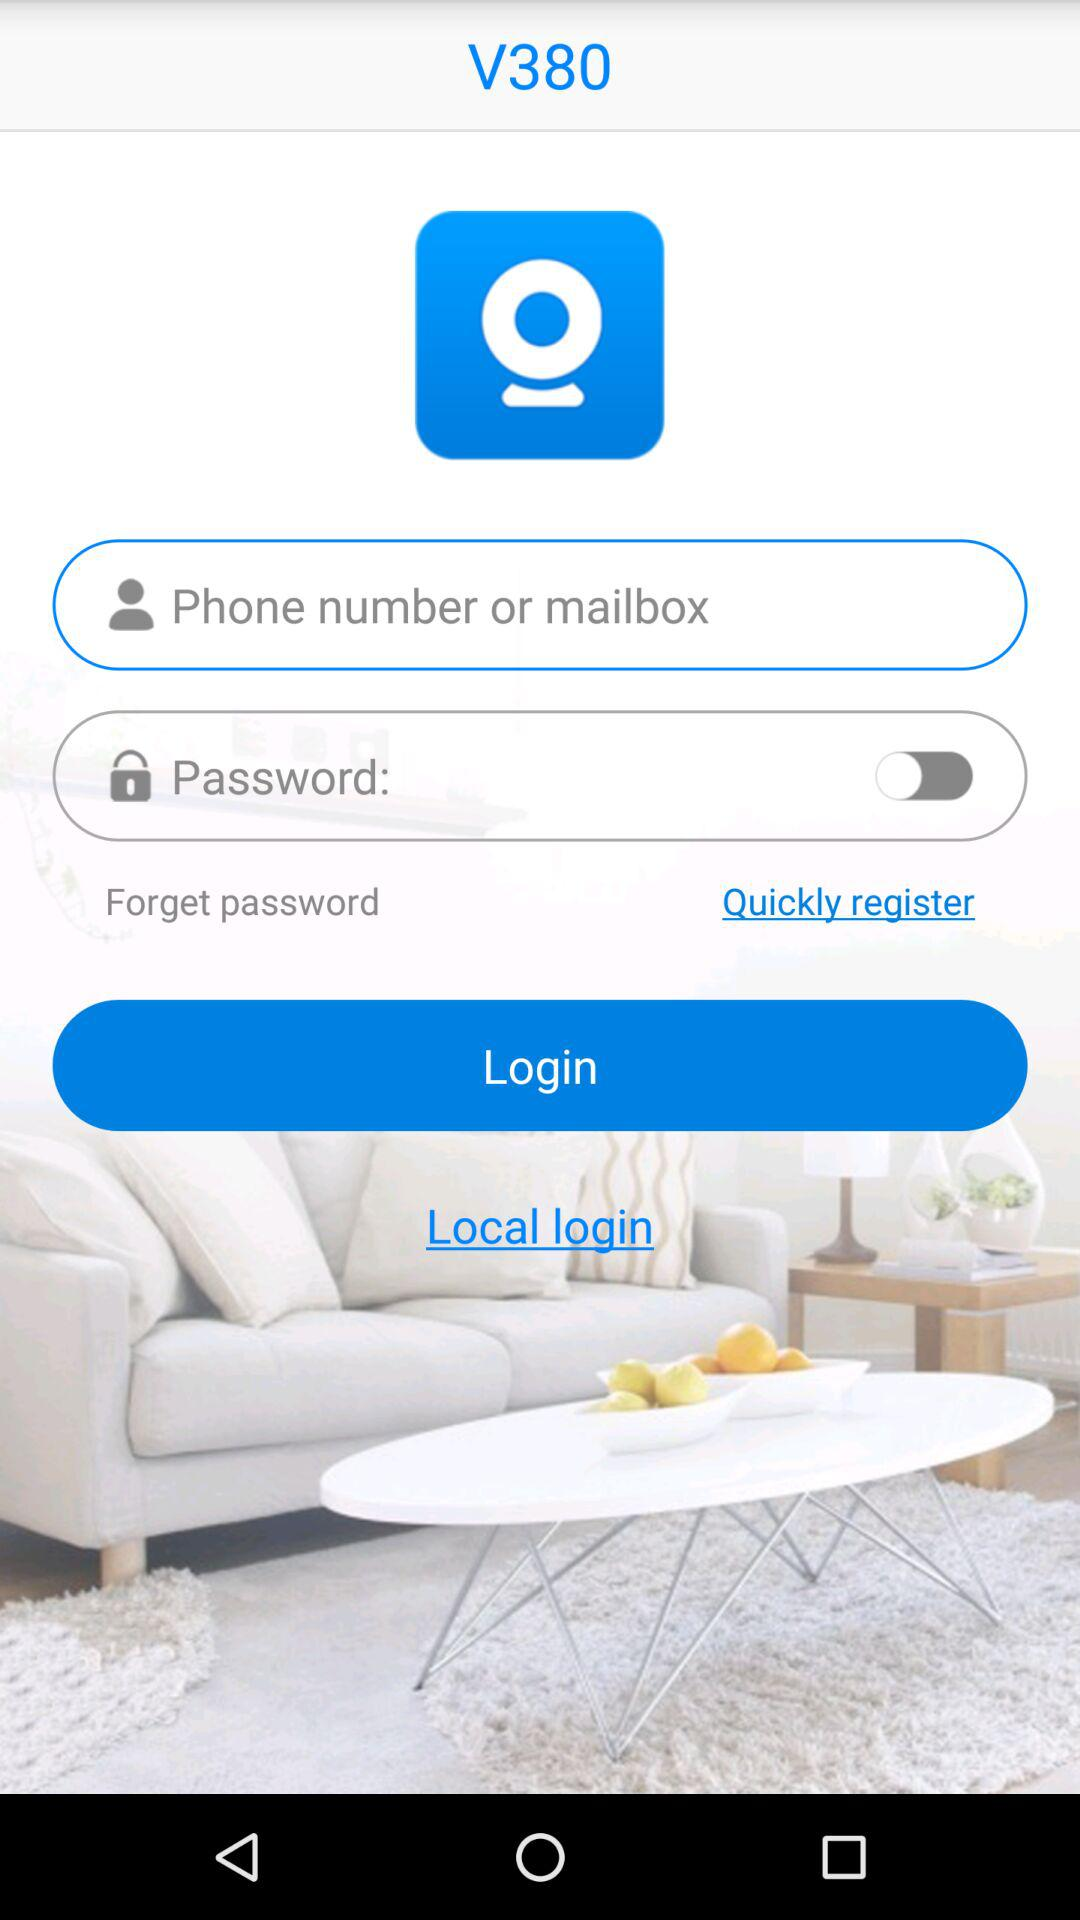What is the local login?
When the provided information is insufficient, respond with <no answer>. <no answer> 